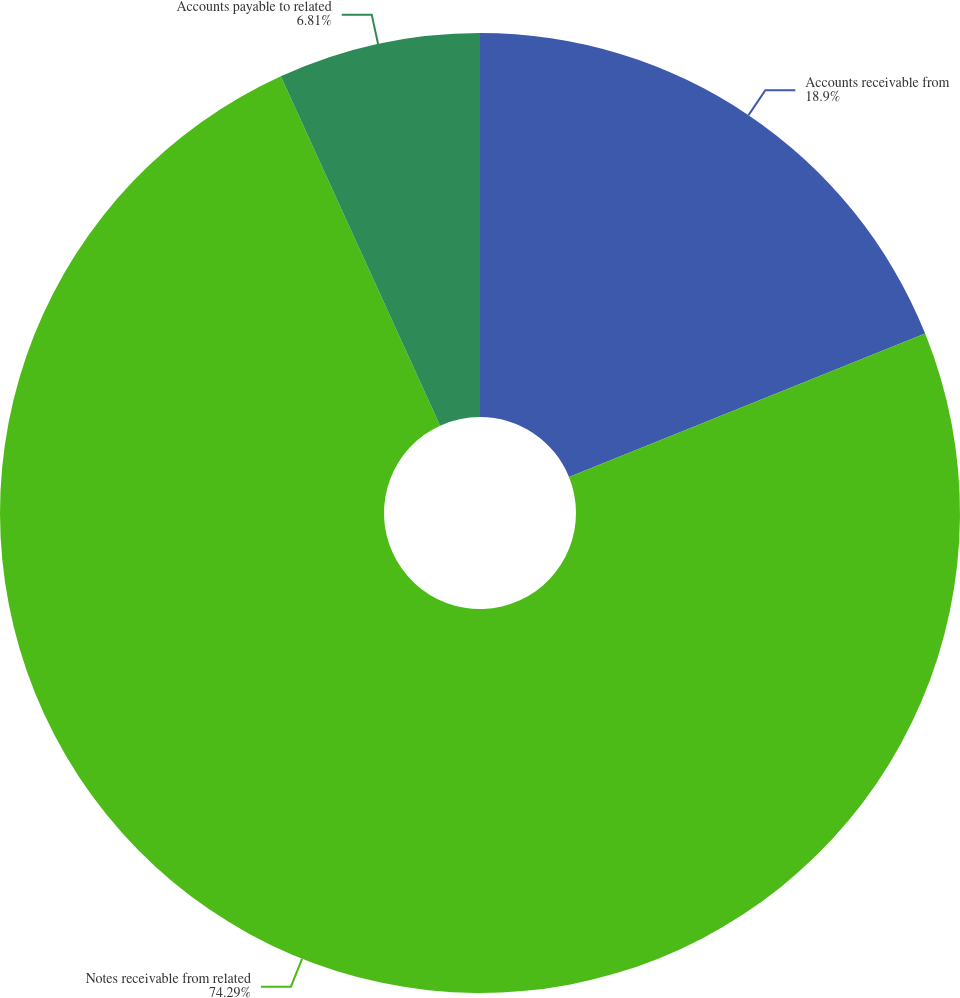<chart> <loc_0><loc_0><loc_500><loc_500><pie_chart><fcel>Accounts receivable from<fcel>Notes receivable from related<fcel>Accounts payable to related<nl><fcel>18.9%<fcel>74.29%<fcel>6.81%<nl></chart> 